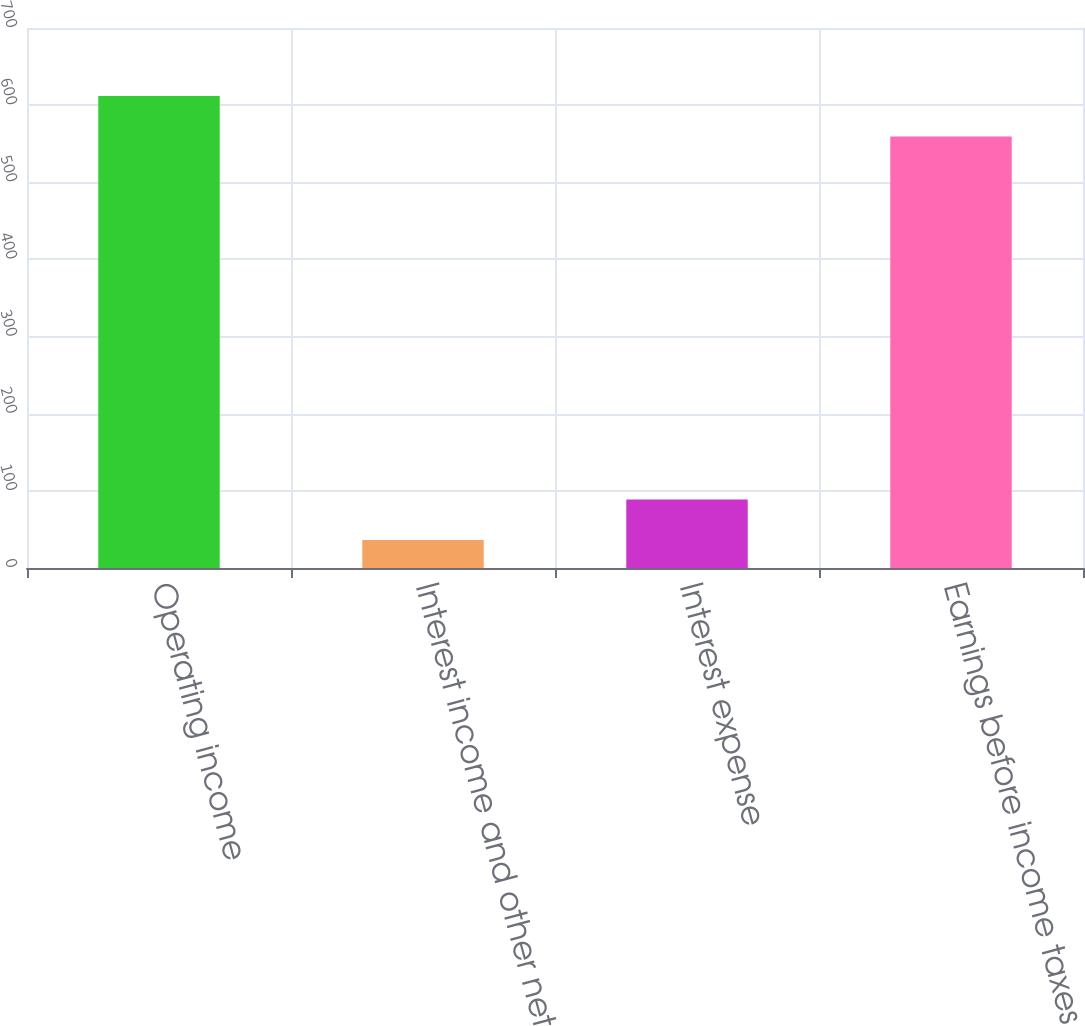Convert chart to OTSL. <chart><loc_0><loc_0><loc_500><loc_500><bar_chart><fcel>Operating income<fcel>Interest income and other net<fcel>Interest expense<fcel>Earnings before income taxes<nl><fcel>611.77<fcel>36.3<fcel>88.87<fcel>559.2<nl></chart> 